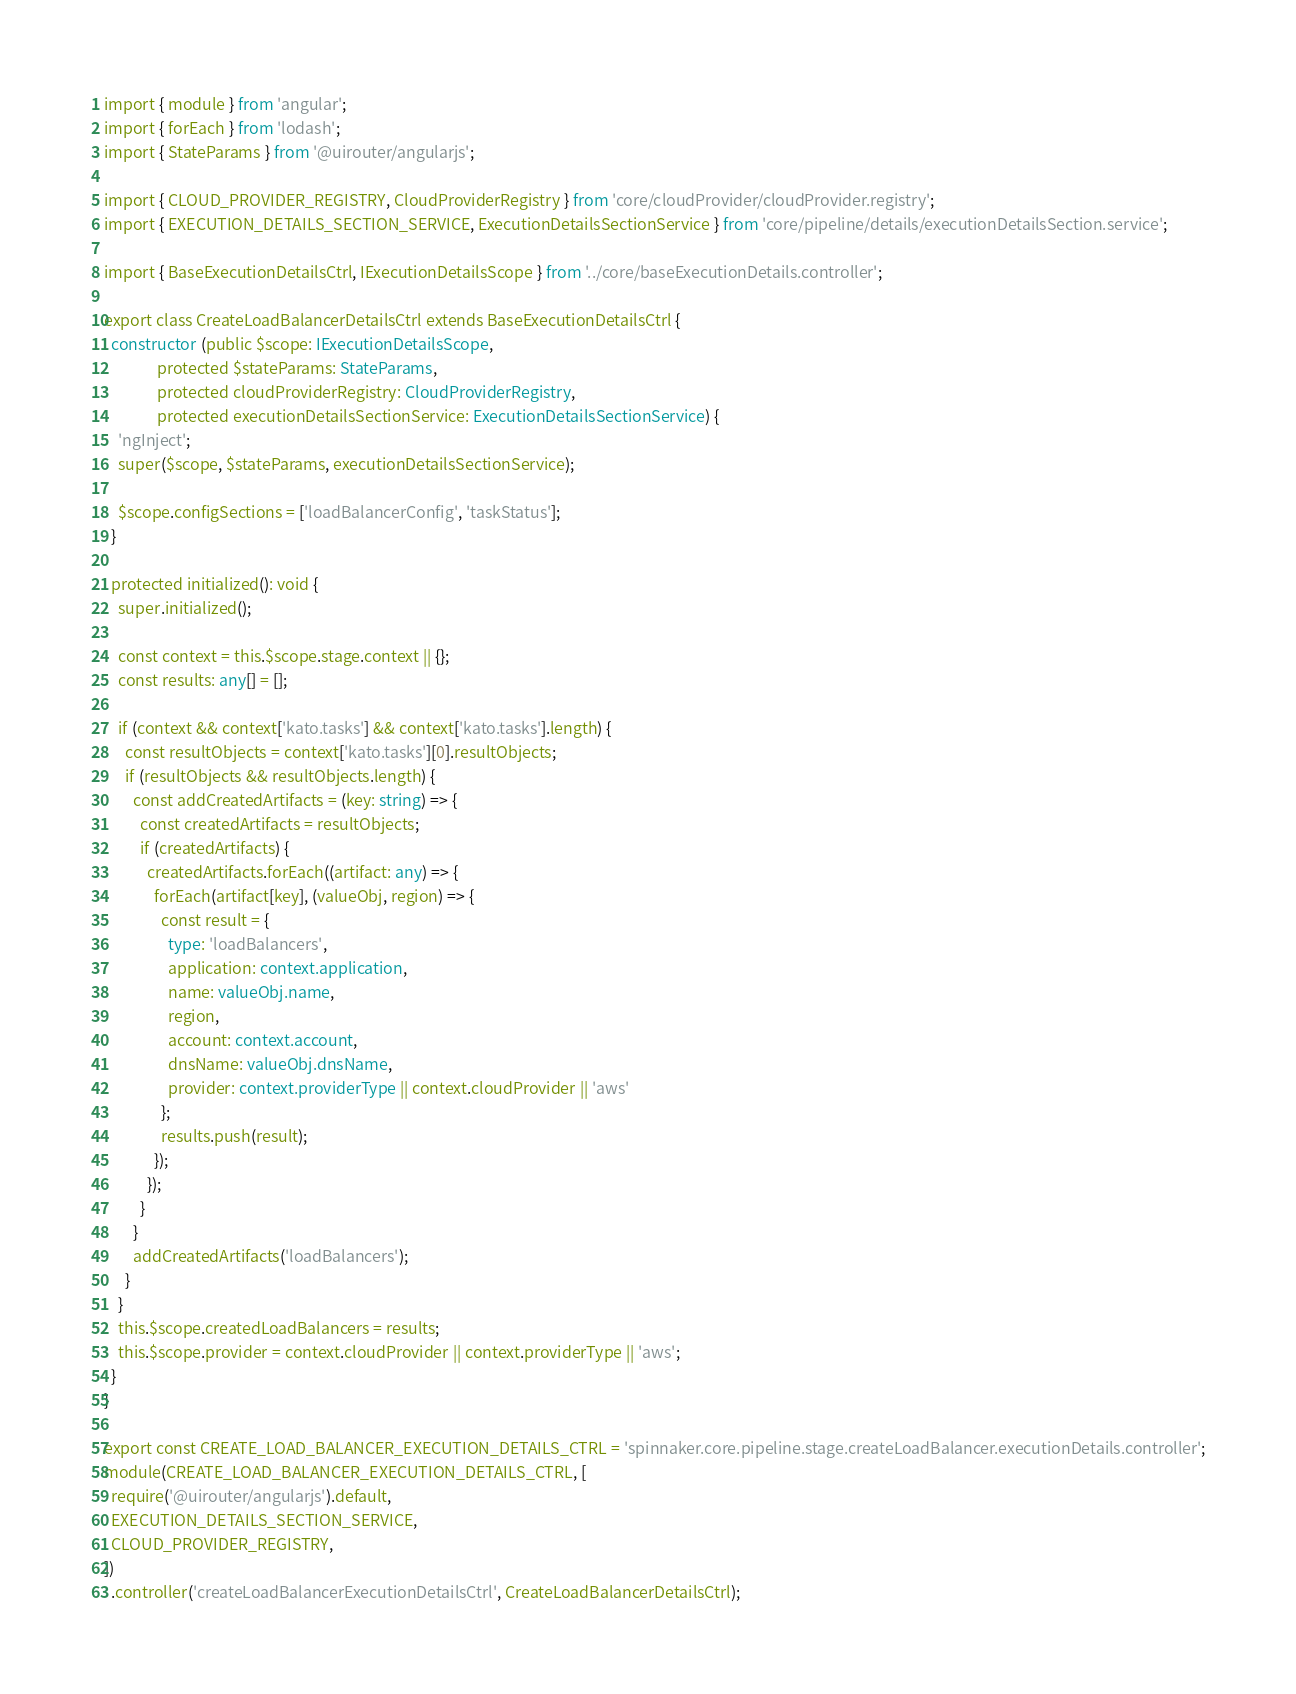Convert code to text. <code><loc_0><loc_0><loc_500><loc_500><_TypeScript_>import { module } from 'angular';
import { forEach } from 'lodash';
import { StateParams } from '@uirouter/angularjs';

import { CLOUD_PROVIDER_REGISTRY, CloudProviderRegistry } from 'core/cloudProvider/cloudProvider.registry';
import { EXECUTION_DETAILS_SECTION_SERVICE, ExecutionDetailsSectionService } from 'core/pipeline/details/executionDetailsSection.service';

import { BaseExecutionDetailsCtrl, IExecutionDetailsScope } from '../core/baseExecutionDetails.controller';

export class CreateLoadBalancerDetailsCtrl extends BaseExecutionDetailsCtrl {
  constructor (public $scope: IExecutionDetailsScope,
               protected $stateParams: StateParams,
               protected cloudProviderRegistry: CloudProviderRegistry,
               protected executionDetailsSectionService: ExecutionDetailsSectionService) {
    'ngInject';
    super($scope, $stateParams, executionDetailsSectionService);

    $scope.configSections = ['loadBalancerConfig', 'taskStatus'];
  }

  protected initialized(): void {
    super.initialized();

    const context = this.$scope.stage.context || {};
    const results: any[] = [];

    if (context && context['kato.tasks'] && context['kato.tasks'].length) {
      const resultObjects = context['kato.tasks'][0].resultObjects;
      if (resultObjects && resultObjects.length) {
        const addCreatedArtifacts = (key: string) => {
          const createdArtifacts = resultObjects;
          if (createdArtifacts) {
            createdArtifacts.forEach((artifact: any) => {
              forEach(artifact[key], (valueObj, region) => {
                const result = {
                  type: 'loadBalancers',
                  application: context.application,
                  name: valueObj.name,
                  region,
                  account: context.account,
                  dnsName: valueObj.dnsName,
                  provider: context.providerType || context.cloudProvider || 'aws'
                };
                results.push(result);
              });
            });
          }
        }
        addCreatedArtifacts('loadBalancers');
      }
    }
    this.$scope.createdLoadBalancers = results;
    this.$scope.provider = context.cloudProvider || context.providerType || 'aws';
  }
}

export const CREATE_LOAD_BALANCER_EXECUTION_DETAILS_CTRL = 'spinnaker.core.pipeline.stage.createLoadBalancer.executionDetails.controller';
module(CREATE_LOAD_BALANCER_EXECUTION_DETAILS_CTRL, [
  require('@uirouter/angularjs').default,
  EXECUTION_DETAILS_SECTION_SERVICE,
  CLOUD_PROVIDER_REGISTRY,
])
  .controller('createLoadBalancerExecutionDetailsCtrl', CreateLoadBalancerDetailsCtrl);
</code> 